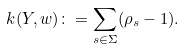<formula> <loc_0><loc_0><loc_500><loc_500>k ( Y , w ) \colon = \sum _ { s \in \Sigma } ( \rho _ { s } - 1 ) .</formula> 